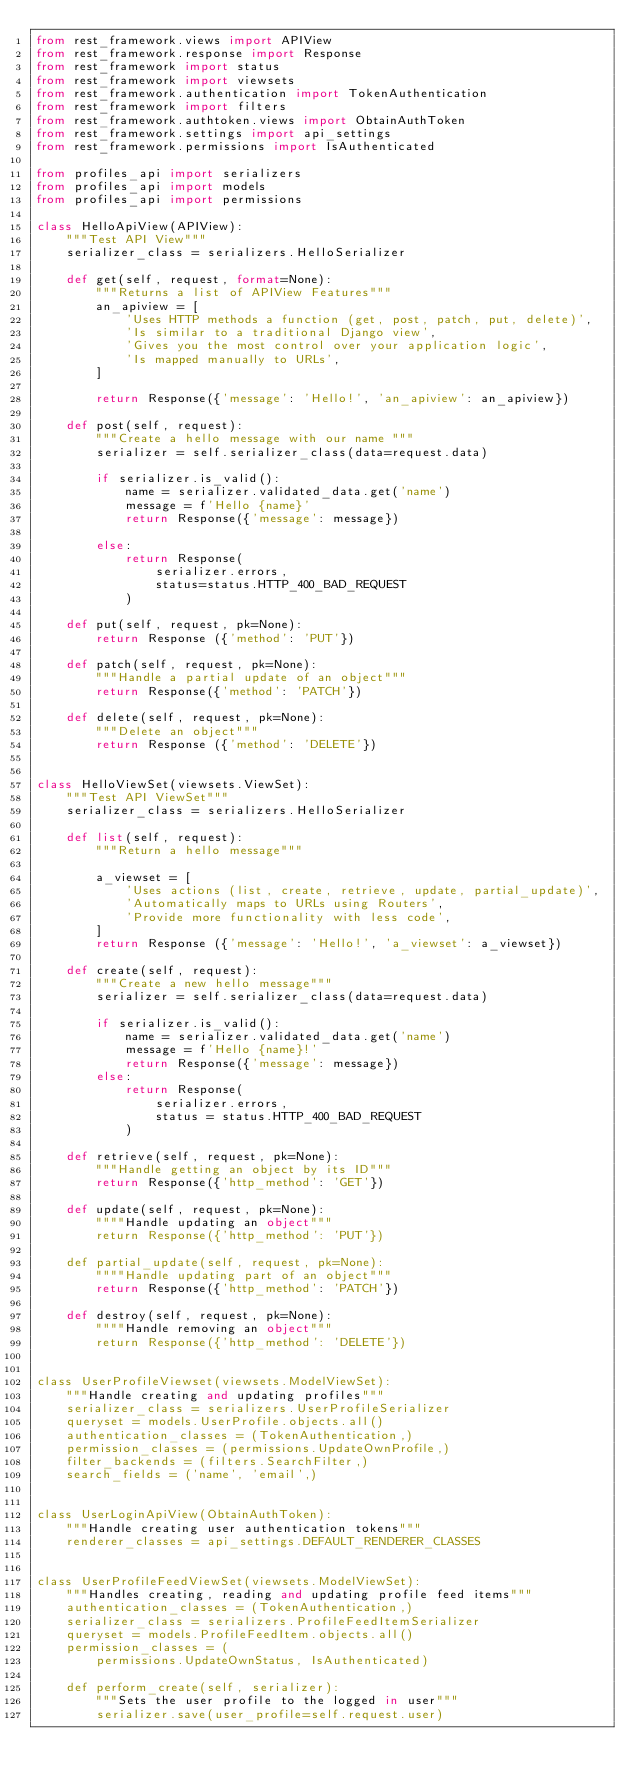<code> <loc_0><loc_0><loc_500><loc_500><_Python_>from rest_framework.views import APIView
from rest_framework.response import Response
from rest_framework import status
from rest_framework import viewsets
from rest_framework.authentication import TokenAuthentication
from rest_framework import filters
from rest_framework.authtoken.views import ObtainAuthToken
from rest_framework.settings import api_settings
from rest_framework.permissions import IsAuthenticated

from profiles_api import serializers
from profiles_api import models
from profiles_api import permissions

class HelloApiView(APIView):
    """Test API View"""
    serializer_class = serializers.HelloSerializer

    def get(self, request, format=None):
        """Returns a list of APIView Features"""
        an_apiview = [
            'Uses HTTP methods a function (get, post, patch, put, delete)',
            'Is similar to a traditional Django view',
            'Gives you the most control over your application logic',
            'Is mapped manually to URLs',
        ]

        return Response({'message': 'Hello!', 'an_apiview': an_apiview})

    def post(self, request):
        """Create a hello message with our name """
        serializer = self.serializer_class(data=request.data)

        if serializer.is_valid():
            name = serializer.validated_data.get('name')
            message = f'Hello {name}'
            return Response({'message': message})

        else:
            return Response(
                serializer.errors,
                status=status.HTTP_400_BAD_REQUEST
            )

    def put(self, request, pk=None):
        return Response ({'method': 'PUT'})

    def patch(self, request, pk=None):
        """Handle a partial update of an object"""
        return Response({'method': 'PATCH'})

    def delete(self, request, pk=None):
        """Delete an object"""
        return Response ({'method': 'DELETE'})


class HelloViewSet(viewsets.ViewSet):
    """Test API ViewSet"""
    serializer_class = serializers.HelloSerializer

    def list(self, request):
        """Return a hello message"""

        a_viewset = [
            'Uses actions (list, create, retrieve, update, partial_update)',
            'Automatically maps to URLs using Routers',
            'Provide more functionality with less code',
        ]
        return Response ({'message': 'Hello!', 'a_viewset': a_viewset})

    def create(self, request):
        """Create a new hello message"""
        serializer = self.serializer_class(data=request.data)

        if serializer.is_valid():
            name = serializer.validated_data.get('name')
            message = f'Hello {name}!'
            return Response({'message': message})
        else:
            return Response(
                serializer.errors,
                status = status.HTTP_400_BAD_REQUEST
            )

    def retrieve(self, request, pk=None):
        """Handle getting an object by its ID"""
        return Response({'http_method': 'GET'})

    def update(self, request, pk=None):
        """"Handle updating an object"""
        return Response({'http_method': 'PUT'})

    def partial_update(self, request, pk=None):
        """"Handle updating part of an object"""
        return Response({'http_method': 'PATCH'})

    def destroy(self, request, pk=None):
        """"Handle removing an object"""
        return Response({'http_method': 'DELETE'})


class UserProfileViewset(viewsets.ModelViewSet):
    """Handle creating and updating profiles"""
    serializer_class = serializers.UserProfileSerializer
    queryset = models.UserProfile.objects.all()
    authentication_classes = (TokenAuthentication,)
    permission_classes = (permissions.UpdateOwnProfile,)
    filter_backends = (filters.SearchFilter,)
    search_fields = ('name', 'email',)


class UserLoginApiView(ObtainAuthToken):
    """Handle creating user authentication tokens"""
    renderer_classes = api_settings.DEFAULT_RENDERER_CLASSES


class UserProfileFeedViewSet(viewsets.ModelViewSet):
    """Handles creating, reading and updating profile feed items"""
    authentication_classes = (TokenAuthentication,)
    serializer_class = serializers.ProfileFeedItemSerializer
    queryset = models.ProfileFeedItem.objects.all()
    permission_classes = (
        permissions.UpdateOwnStatus, IsAuthenticated)

    def perform_create(self, serializer):
        """Sets the user profile to the logged in user"""
        serializer.save(user_profile=self.request.user)
</code> 